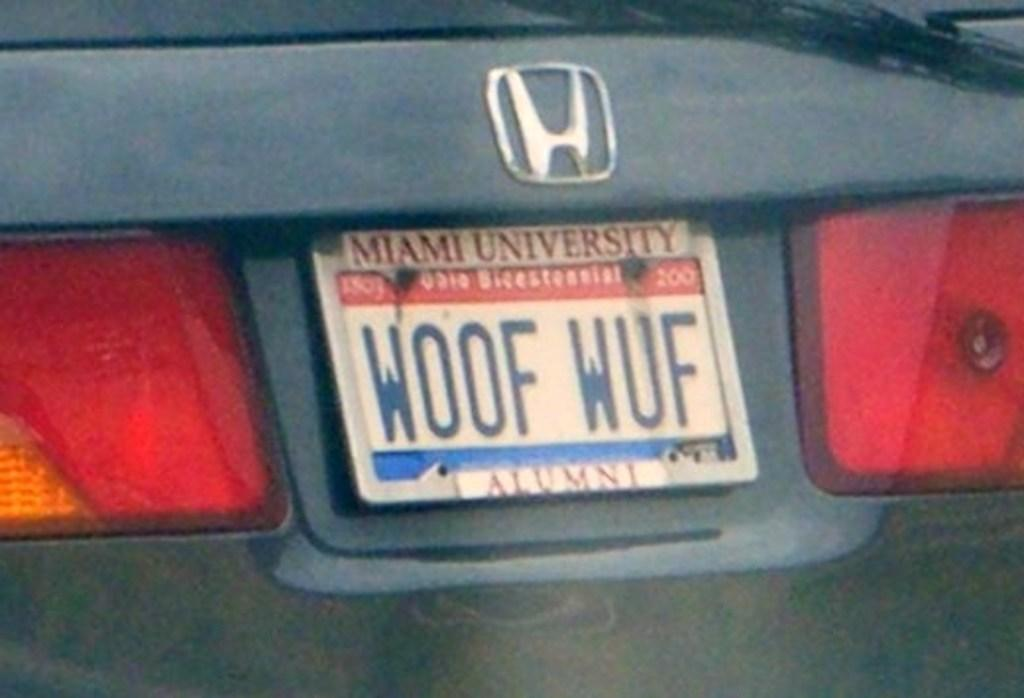<image>
Summarize the visual content of the image. a license plate that has woof wuf on it 